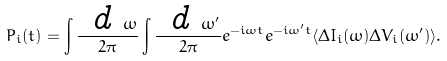Convert formula to latex. <formula><loc_0><loc_0><loc_500><loc_500>P _ { i } ( t ) = \int \frac { \emph { d } \omega } { 2 \pi } \int \frac { \emph { d } \omega ^ { \prime } } { 2 \pi } e ^ { - i \omega t } e ^ { - i \omega ^ { \prime } t } \langle \Delta I _ { i } ( \omega ) \Delta V _ { i } ( \omega ^ { \prime } ) \rangle .</formula> 